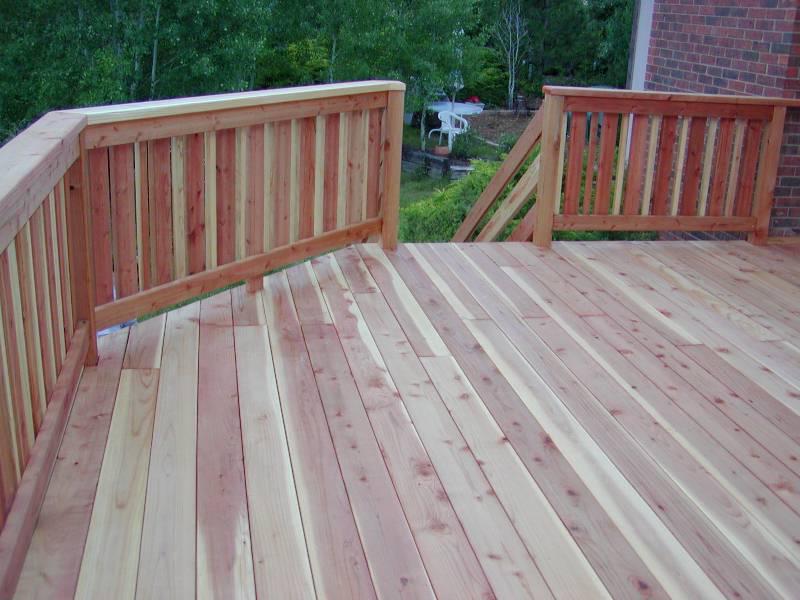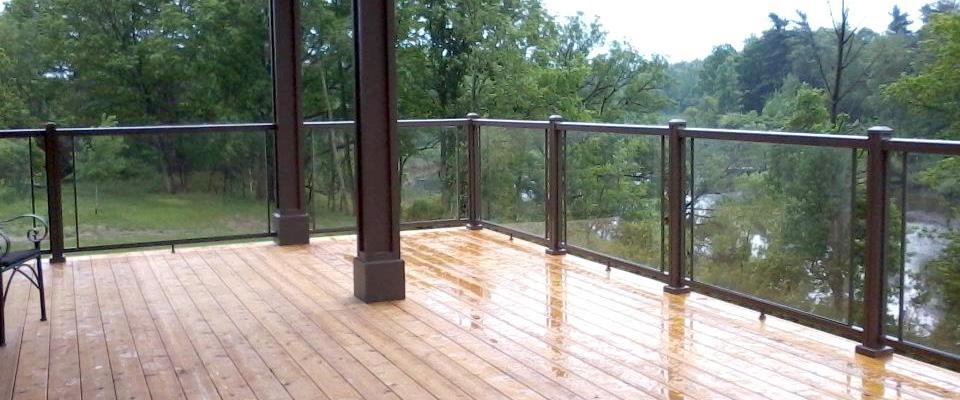The first image is the image on the left, the second image is the image on the right. Considering the images on both sides, is "The left image contains a deck with unpainted wood rails with mesh sides, and the right image shows a deck with light painted vertical rails with square-capped posts." valid? Answer yes or no. No. The first image is the image on the left, the second image is the image on the right. Considering the images on both sides, is "At least one railing is white." valid? Answer yes or no. No. 